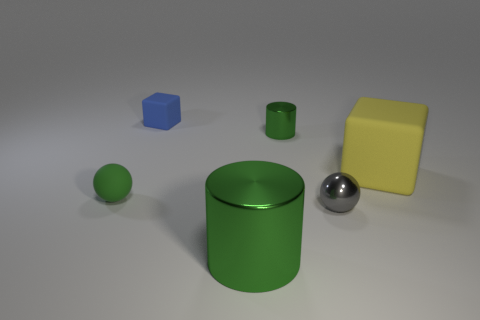Can you describe the shapes and the arrangement of the objects in the image? Certainly. The image features a collection of geometric shapes arranged haphazardly. There's a cube, a sphere, and two cylinders with varying heights. Their positioning seems random, with no discernible pattern, providing an almost minimalist or abstract art composition. 